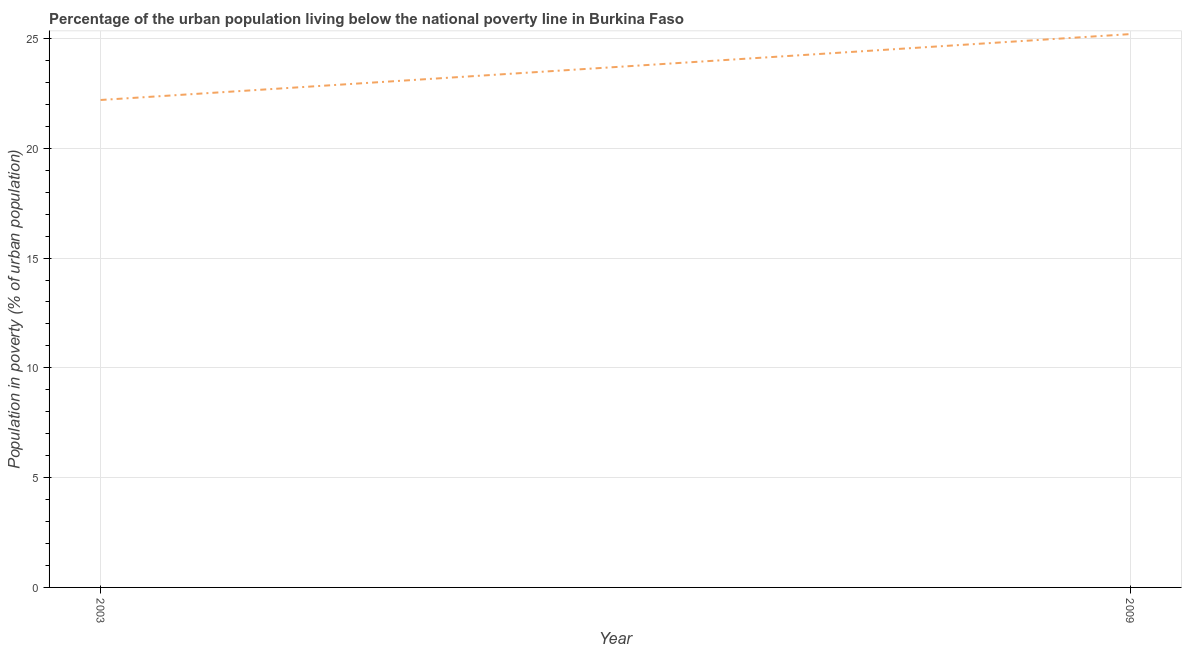Across all years, what is the maximum percentage of urban population living below poverty line?
Provide a short and direct response. 25.2. In which year was the percentage of urban population living below poverty line maximum?
Your answer should be very brief. 2009. In which year was the percentage of urban population living below poverty line minimum?
Provide a short and direct response. 2003. What is the sum of the percentage of urban population living below poverty line?
Provide a succinct answer. 47.4. What is the difference between the percentage of urban population living below poverty line in 2003 and 2009?
Ensure brevity in your answer.  -3. What is the average percentage of urban population living below poverty line per year?
Your answer should be compact. 23.7. What is the median percentage of urban population living below poverty line?
Offer a very short reply. 23.7. What is the ratio of the percentage of urban population living below poverty line in 2003 to that in 2009?
Make the answer very short. 0.88. Is the percentage of urban population living below poverty line in 2003 less than that in 2009?
Make the answer very short. Yes. In how many years, is the percentage of urban population living below poverty line greater than the average percentage of urban population living below poverty line taken over all years?
Offer a very short reply. 1. Does the percentage of urban population living below poverty line monotonically increase over the years?
Make the answer very short. Yes. How many lines are there?
Make the answer very short. 1. Does the graph contain any zero values?
Your response must be concise. No. What is the title of the graph?
Make the answer very short. Percentage of the urban population living below the national poverty line in Burkina Faso. What is the label or title of the Y-axis?
Make the answer very short. Population in poverty (% of urban population). What is the Population in poverty (% of urban population) of 2009?
Keep it short and to the point. 25.2. What is the difference between the Population in poverty (% of urban population) in 2003 and 2009?
Your answer should be very brief. -3. What is the ratio of the Population in poverty (% of urban population) in 2003 to that in 2009?
Provide a short and direct response. 0.88. 